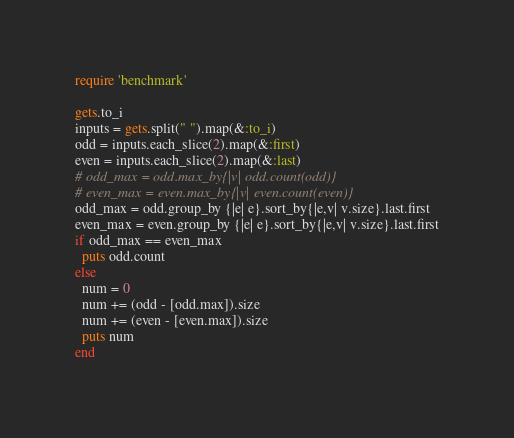<code> <loc_0><loc_0><loc_500><loc_500><_Ruby_>require 'benchmark'

gets.to_i
inputs = gets.split(" ").map(&:to_i)
odd = inputs.each_slice(2).map(&:first)
even = inputs.each_slice(2).map(&:last)
# odd_max = odd.max_by{|v| odd.count(odd)}
# even_max = even.max_by{|v| even.count(even)}
odd_max = odd.group_by {|e| e}.sort_by{|e,v| v.size}.last.first
even_max = even.group_by {|e| e}.sort_by{|e,v| v.size}.last.first
if odd_max == even_max
  puts odd.count
else
  num = 0
  num += (odd - [odd.max]).size
  num += (even - [even.max]).size
  puts num
end</code> 